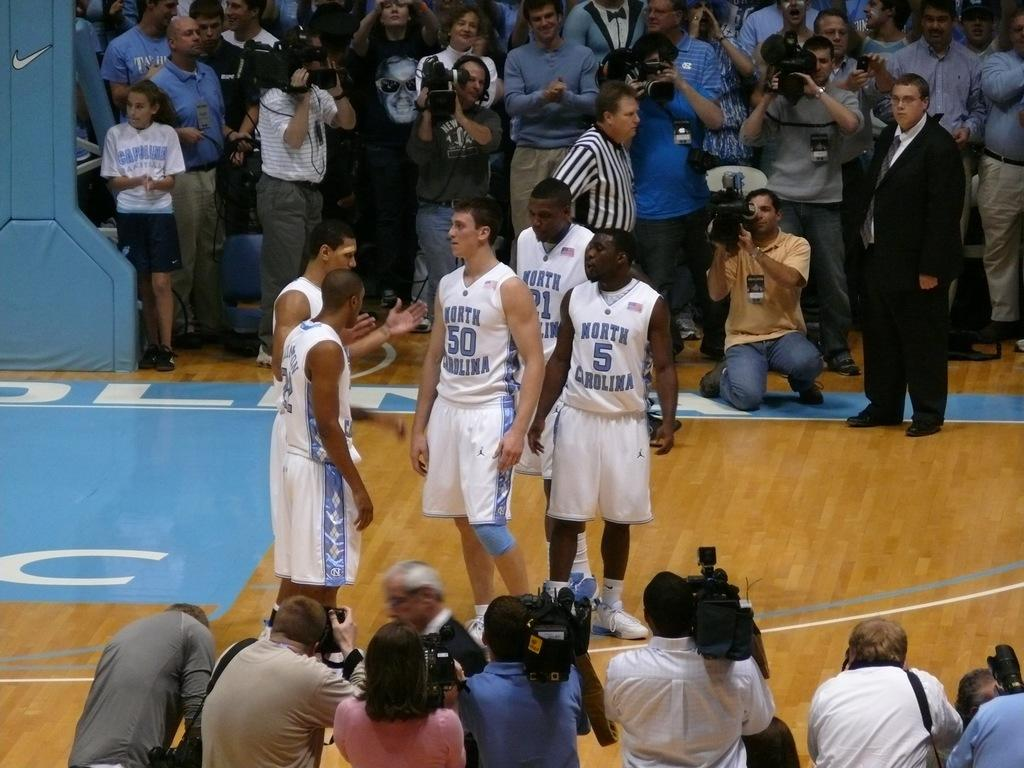Who or what can be seen in the image? There are people in the image. Can you describe any specific features or objects in the image? Yes, there is a pillar in the top left corner of the image. What type of riddle is being solved by the people in the image? There is no riddle present in the image; it only shows people and a pillar. Can you tell me how many kettles are visible in the image? There are no kettles present in the image. 